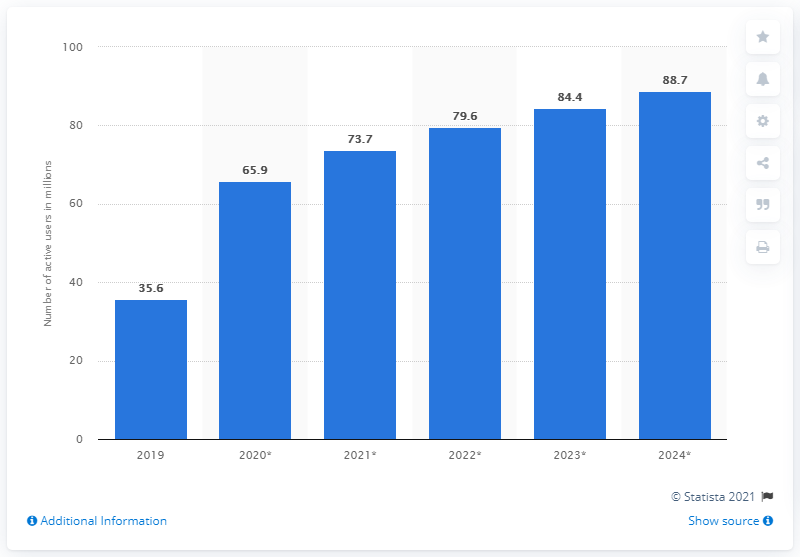Identify some key points in this picture. TikTok had a user base of 73.7 million in 2020. In 2020, TikTok had 65.9 million users in the United States. 